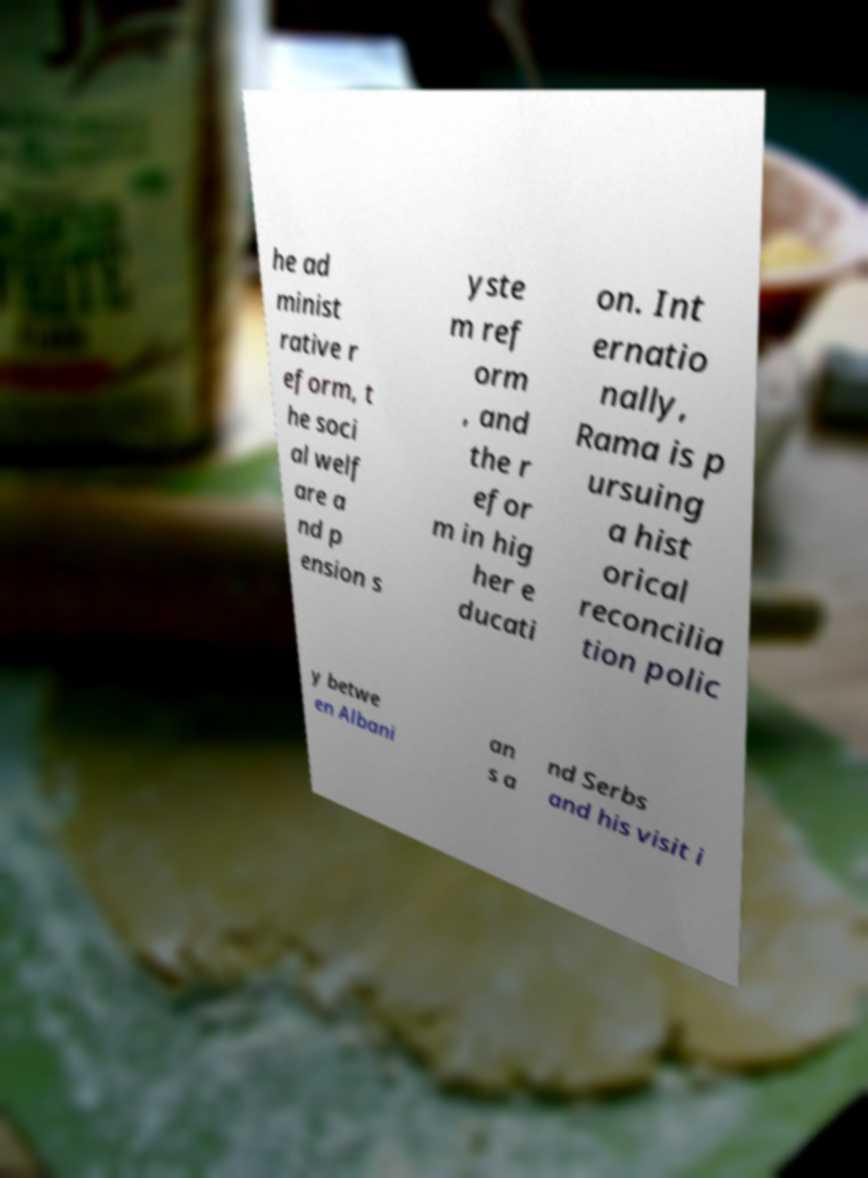Can you read and provide the text displayed in the image?This photo seems to have some interesting text. Can you extract and type it out for me? he ad minist rative r eform, t he soci al welf are a nd p ension s yste m ref orm , and the r efor m in hig her e ducati on. Int ernatio nally, Rama is p ursuing a hist orical reconcilia tion polic y betwe en Albani an s a nd Serbs and his visit i 